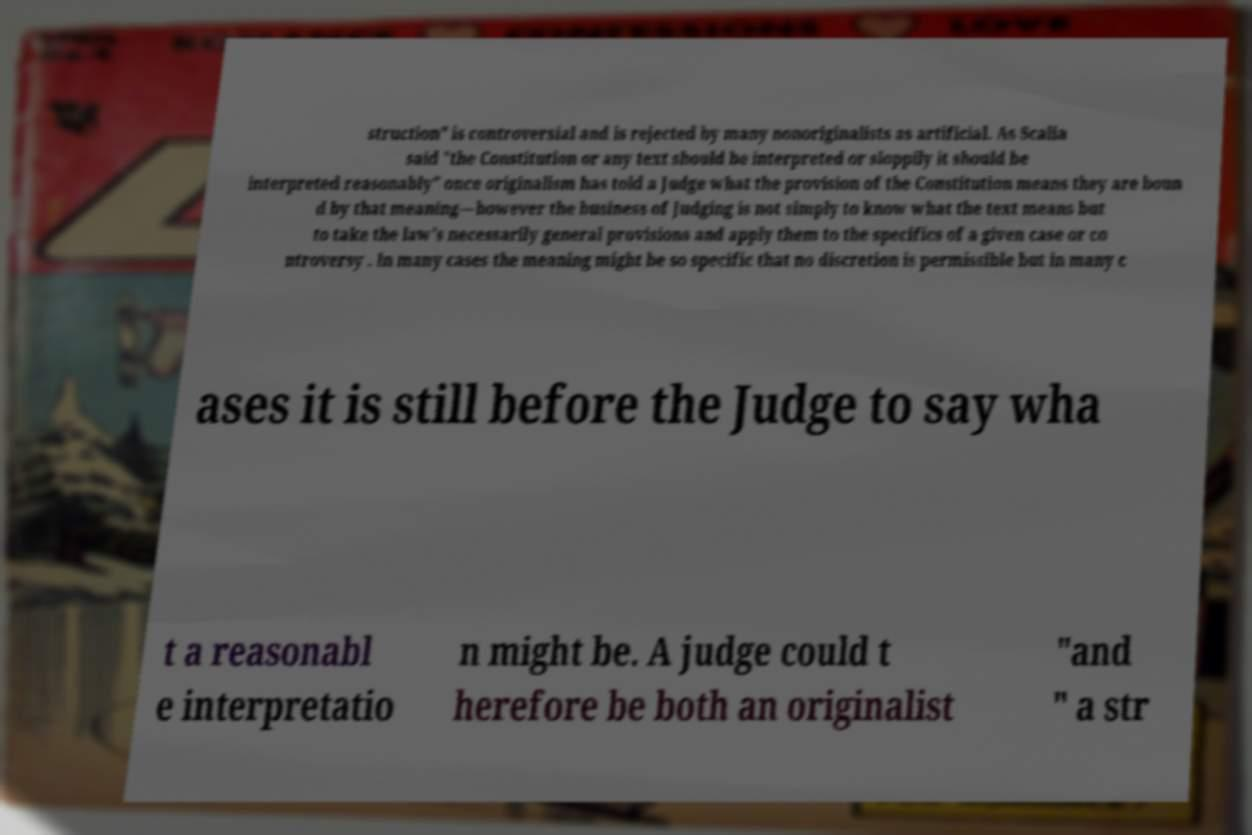What messages or text are displayed in this image? I need them in a readable, typed format. struction" is controversial and is rejected by many nonoriginalists as artificial. As Scalia said "the Constitution or any text should be interpreted or sloppily it should be interpreted reasonably" once originalism has told a Judge what the provision of the Constitution means they are boun d by that meaning—however the business of Judging is not simply to know what the text means but to take the law's necessarily general provisions and apply them to the specifics of a given case or co ntroversy . In many cases the meaning might be so specific that no discretion is permissible but in many c ases it is still before the Judge to say wha t a reasonabl e interpretatio n might be. A judge could t herefore be both an originalist "and " a str 